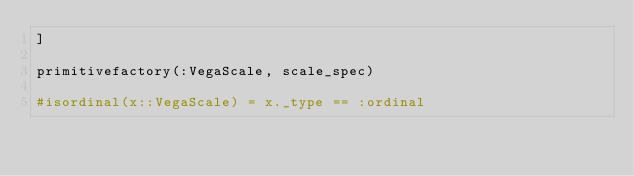Convert code to text. <code><loc_0><loc_0><loc_500><loc_500><_Julia_>]

primitivefactory(:VegaScale, scale_spec)

#isordinal(x::VegaScale) = x._type == :ordinal
</code> 